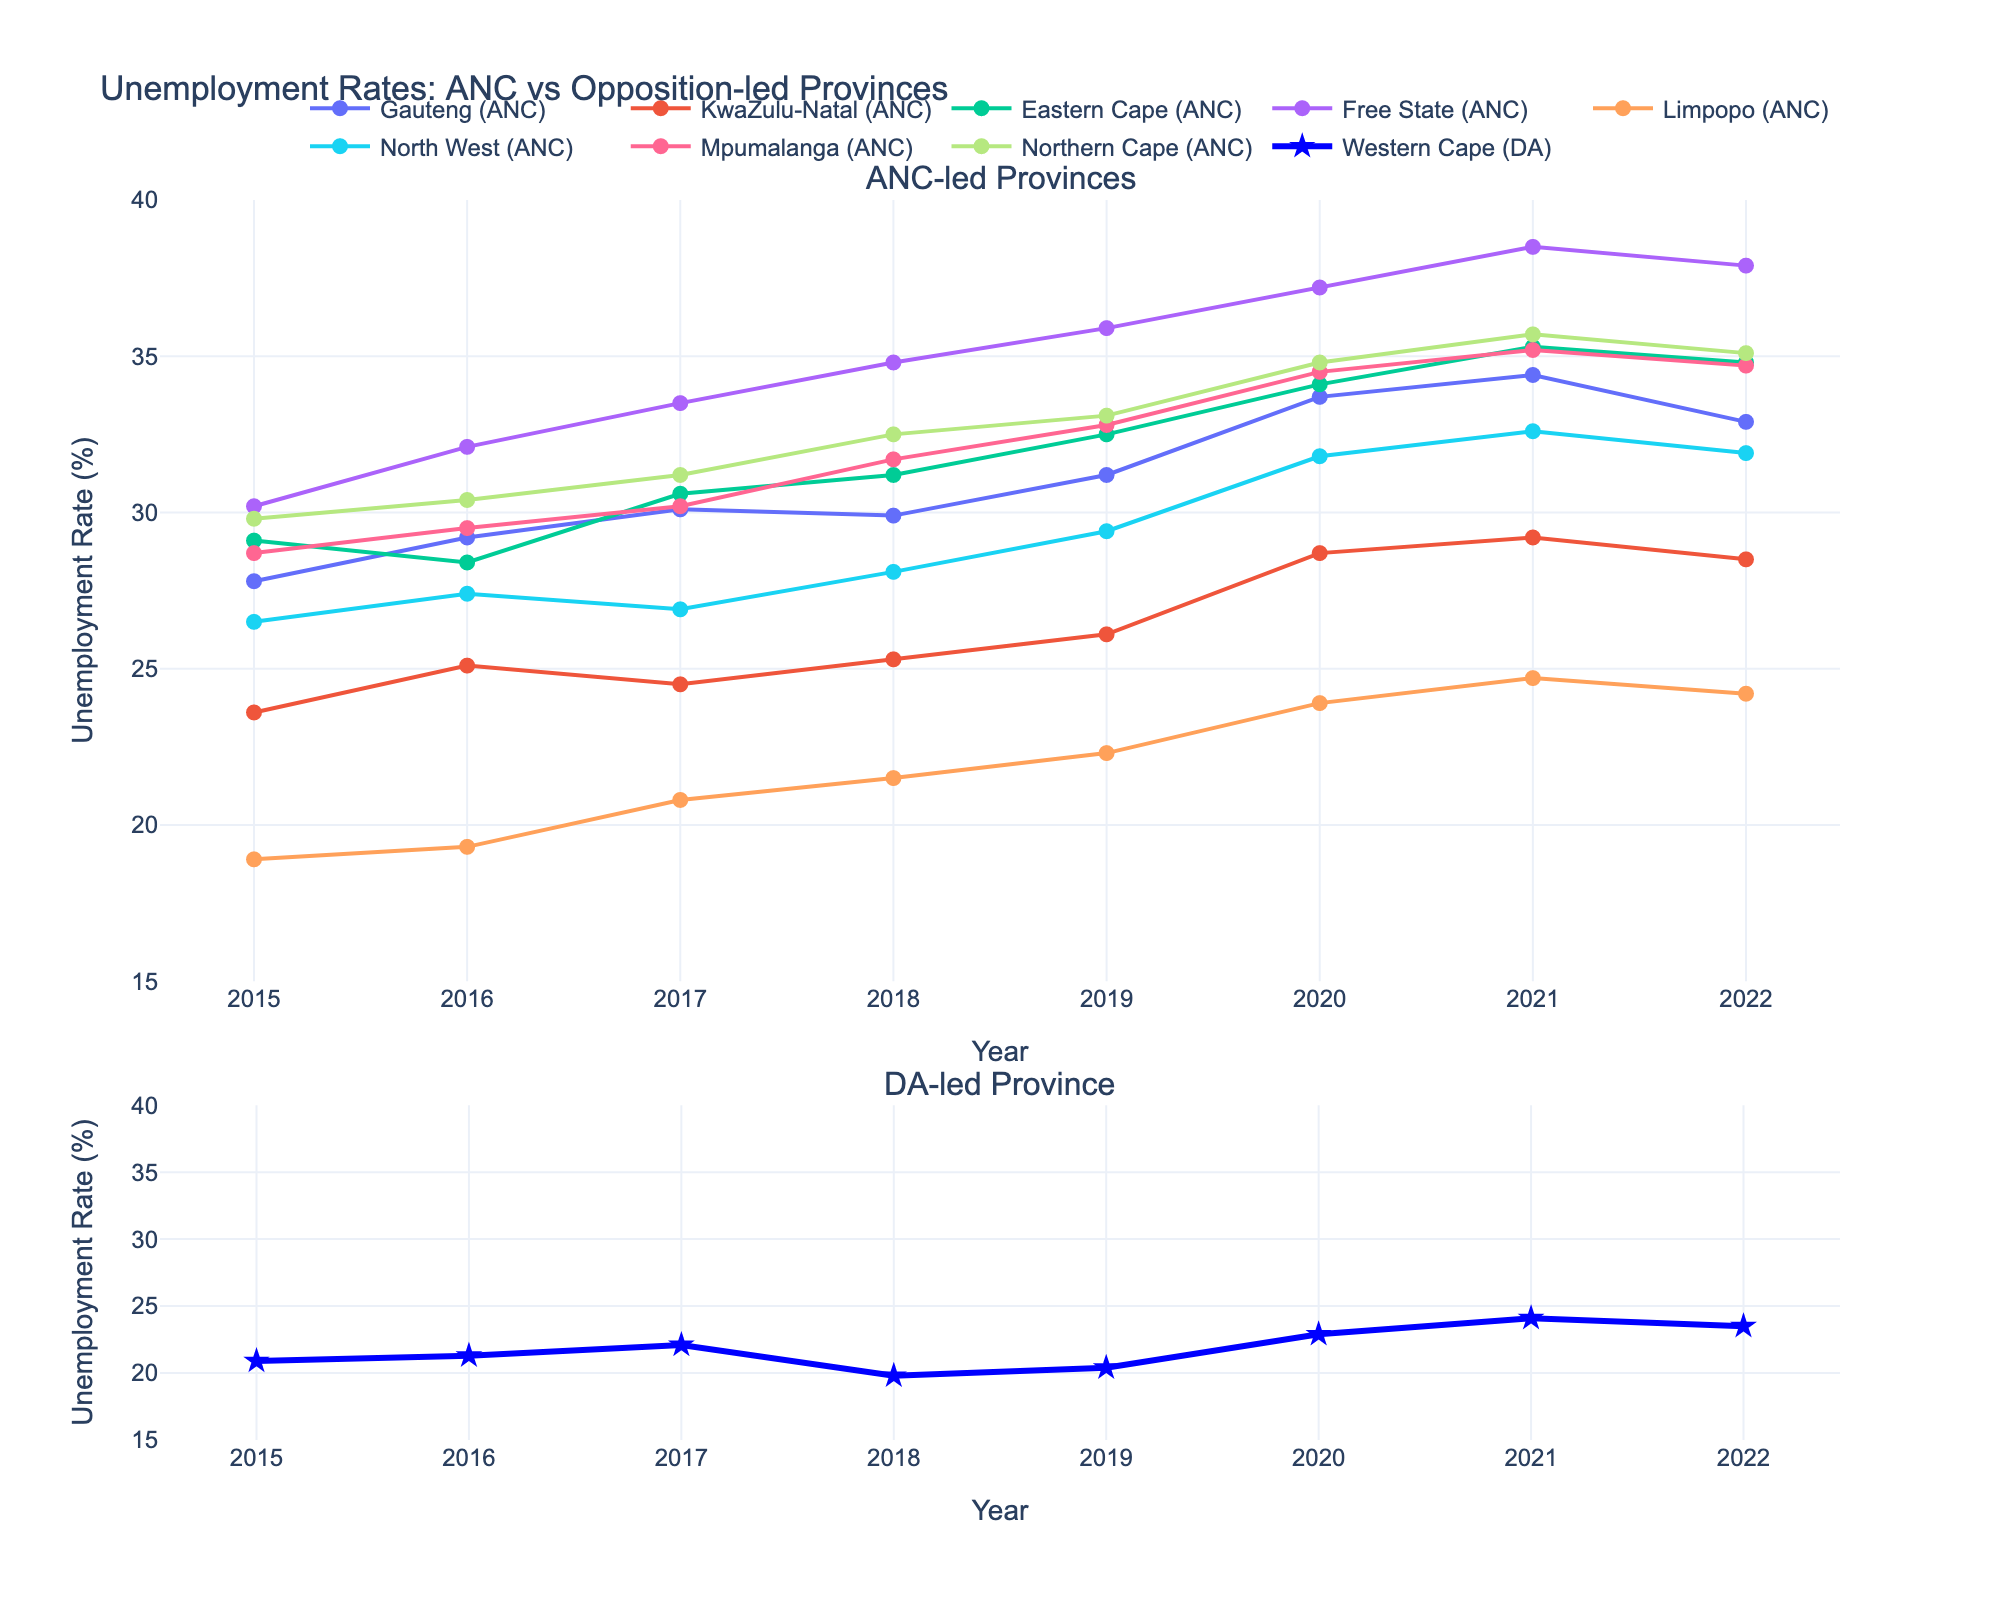What is the title of the figure? The title is located at the top of the figure and provides the overall description of what the figure is representing.
Answer: "Unemployment Rates: ANC vs Opposition-led Provinces" Which provinces are led by the ANC in the figure? The ANC-led provinces are listed in the legend and represented by different colored lines in the top subplot.
Answer: Gauteng, KwaZulu-Natal, Eastern Cape, Free State, Limpopo, North West, Mpumalanga, Northern Cape What is the unemployment rate of the Western Cape in 2020? Look at the value on the blue line with star markers in the bottom subplot at the year 2020.
Answer: 22.9% Which year had the highest unemployment rate in Gauteng? Find the highest peak on the line representing Gauteng in the top subplot and note the corresponding year.
Answer: 2021 Compare the unemployment rates of Free State and Western Cape in 2019. Which province had a higher rate and by how much? Refer to the values of Free State and Western Cape in the respective subplots at the year 2019. Subtract the Western Cape rate from the Free State rate.
Answer: Free State had a higher rate by 15.5% How did the unemployment rate in Limpopo change from 2015 to 2022? Look at the LIMPOPO line in the top subplot and compare the start value at 2015 with the end value at 2022. Find the difference.
Answer: Increased by 5.3% Which ANC-led province had the lowest unemployment rate in 2017? Identify the lowest point among all the ANC-led province lines in the top subplot for the year 2017.
Answer: Limpopo Which year shows the smallest difference in unemployment rates between KwaZulu-Natal and Mpumalanga? Compare the differences between KwaZulu-Natal and Mpumalanga rates across all years and identify the smallest gap.
Answer: 2016 Is there any year where the Western Cape unemployment rate was higher than Gauteng? Compare the Western Cape's unemployment rates in the bottom subplot to Gauteng's rates in the top subplot year by year.
Answer: No What is the average unemployment rate of North West from 2015 to 2022? Sum the unemployment rates for North West from 2015 to 2022 and divide by the number of years (8).
Answer: 29.45% 